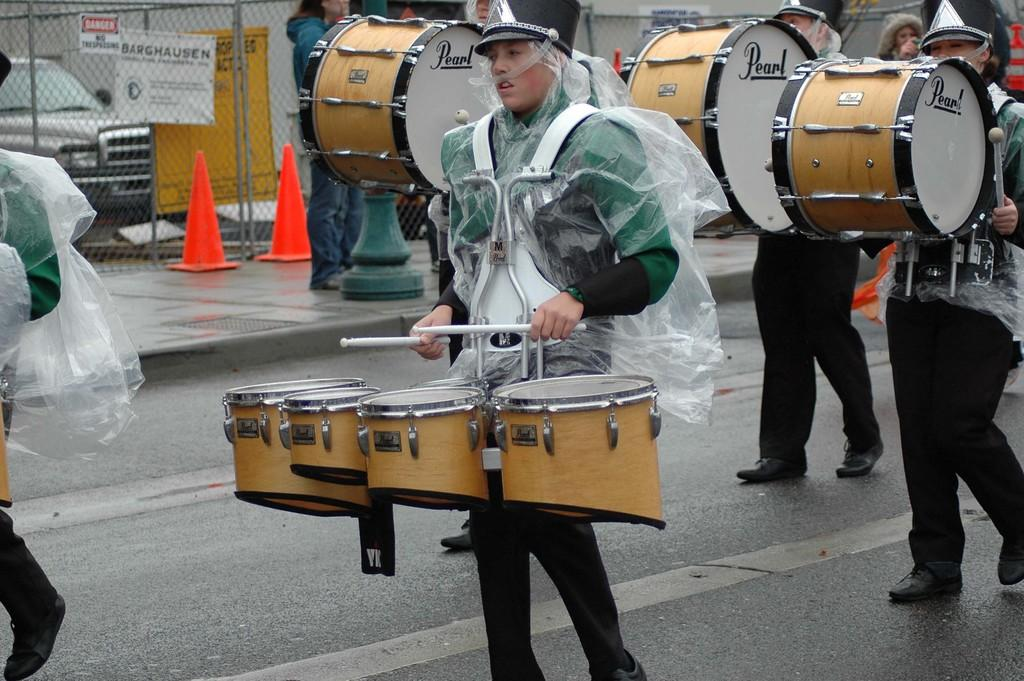What is happening in the image involving the people? The people in the image are moving on the road, and they are holding drums in their hands. What can be seen on the road in the image? There are cones visible in the image. What is parked near the people in the image? A car is parked in the image. What type of barrier is present in the image? There is a metal fence in the image. Where are some people standing in the image? People are standing on the sidewalk. What is the name of the tramp who is performing in the image? There is no tramp performing in the image; the people are holding drums and moving on the road. Is there a railway visible in the image? No, there is no railway present in the image. 